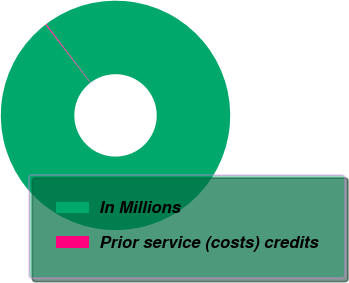Convert chart to OTSL. <chart><loc_0><loc_0><loc_500><loc_500><pie_chart><fcel>In Millions<fcel>Prior service (costs) credits<nl><fcel>99.86%<fcel>0.14%<nl></chart> 